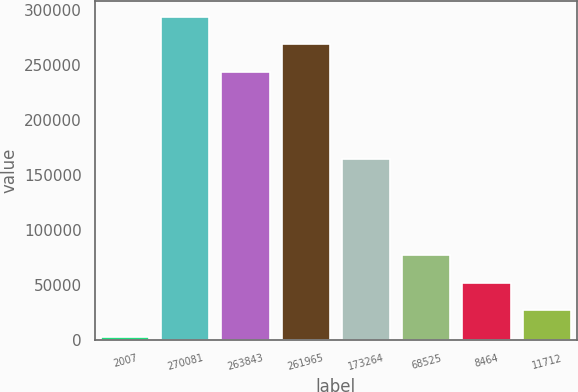Convert chart. <chart><loc_0><loc_0><loc_500><loc_500><bar_chart><fcel>2007<fcel>270081<fcel>263843<fcel>261965<fcel>173264<fcel>68525<fcel>8464<fcel>11712<nl><fcel>2006<fcel>293660<fcel>243819<fcel>268739<fcel>163925<fcel>76766.9<fcel>51846.6<fcel>26926.3<nl></chart> 